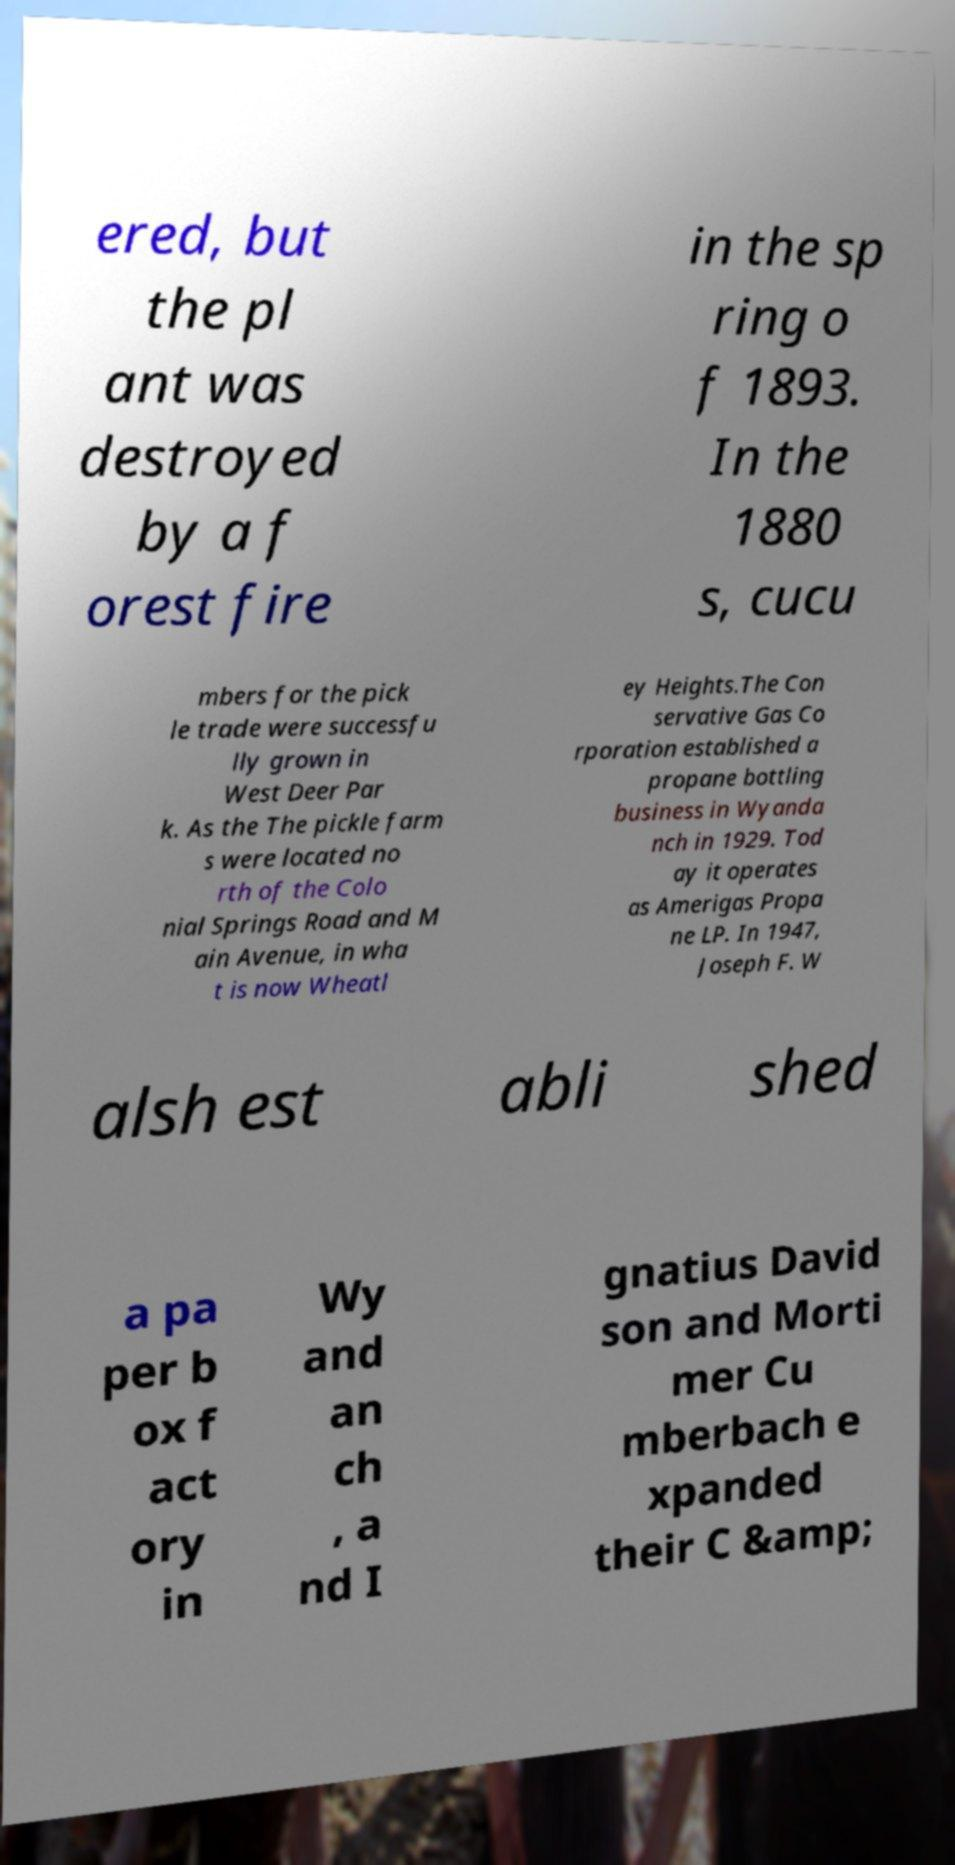Could you assist in decoding the text presented in this image and type it out clearly? ered, but the pl ant was destroyed by a f orest fire in the sp ring o f 1893. In the 1880 s, cucu mbers for the pick le trade were successfu lly grown in West Deer Par k. As the The pickle farm s were located no rth of the Colo nial Springs Road and M ain Avenue, in wha t is now Wheatl ey Heights.The Con servative Gas Co rporation established a propane bottling business in Wyanda nch in 1929. Tod ay it operates as Amerigas Propa ne LP. In 1947, Joseph F. W alsh est abli shed a pa per b ox f act ory in Wy and an ch , a nd I gnatius David son and Morti mer Cu mberbach e xpanded their C &amp; 